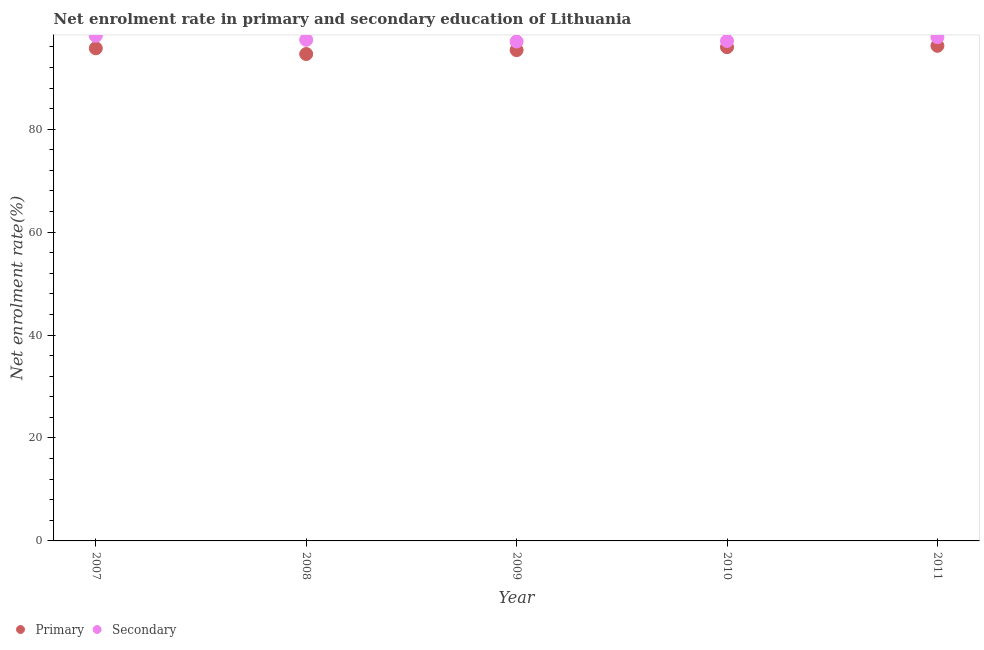How many different coloured dotlines are there?
Provide a short and direct response. 2. Is the number of dotlines equal to the number of legend labels?
Provide a short and direct response. Yes. What is the enrollment rate in secondary education in 2007?
Ensure brevity in your answer.  98.15. Across all years, what is the maximum enrollment rate in secondary education?
Provide a succinct answer. 98.15. Across all years, what is the minimum enrollment rate in secondary education?
Offer a very short reply. 97.03. In which year was the enrollment rate in secondary education maximum?
Your response must be concise. 2007. What is the total enrollment rate in primary education in the graph?
Your answer should be compact. 477.82. What is the difference between the enrollment rate in secondary education in 2009 and that in 2010?
Your answer should be compact. -0.11. What is the difference between the enrollment rate in primary education in 2007 and the enrollment rate in secondary education in 2010?
Offer a terse response. -1.43. What is the average enrollment rate in primary education per year?
Give a very brief answer. 95.56. In the year 2011, what is the difference between the enrollment rate in secondary education and enrollment rate in primary education?
Offer a terse response. 1.67. What is the ratio of the enrollment rate in secondary education in 2009 to that in 2010?
Offer a terse response. 1. What is the difference between the highest and the second highest enrollment rate in secondary education?
Your answer should be very brief. 0.27. What is the difference between the highest and the lowest enrollment rate in primary education?
Give a very brief answer. 1.6. In how many years, is the enrollment rate in primary education greater than the average enrollment rate in primary education taken over all years?
Offer a very short reply. 3. Is the sum of the enrollment rate in secondary education in 2007 and 2011 greater than the maximum enrollment rate in primary education across all years?
Your answer should be compact. Yes. Is the enrollment rate in secondary education strictly greater than the enrollment rate in primary education over the years?
Your response must be concise. Yes. How many dotlines are there?
Your answer should be very brief. 2. How many years are there in the graph?
Your response must be concise. 5. What is the difference between two consecutive major ticks on the Y-axis?
Ensure brevity in your answer.  20. Are the values on the major ticks of Y-axis written in scientific E-notation?
Your answer should be very brief. No. Does the graph contain grids?
Make the answer very short. No. What is the title of the graph?
Make the answer very short. Net enrolment rate in primary and secondary education of Lithuania. Does "IMF concessional" appear as one of the legend labels in the graph?
Provide a succinct answer. No. What is the label or title of the X-axis?
Your response must be concise. Year. What is the label or title of the Y-axis?
Ensure brevity in your answer.  Net enrolment rate(%). What is the Net enrolment rate(%) of Primary in 2007?
Make the answer very short. 95.71. What is the Net enrolment rate(%) in Secondary in 2007?
Keep it short and to the point. 98.15. What is the Net enrolment rate(%) of Primary in 2008?
Give a very brief answer. 94.61. What is the Net enrolment rate(%) in Secondary in 2008?
Your response must be concise. 97.37. What is the Net enrolment rate(%) in Primary in 2009?
Your response must be concise. 95.36. What is the Net enrolment rate(%) in Secondary in 2009?
Your answer should be compact. 97.03. What is the Net enrolment rate(%) of Primary in 2010?
Make the answer very short. 95.94. What is the Net enrolment rate(%) in Secondary in 2010?
Provide a short and direct response. 97.15. What is the Net enrolment rate(%) in Primary in 2011?
Keep it short and to the point. 96.2. What is the Net enrolment rate(%) of Secondary in 2011?
Your response must be concise. 97.88. Across all years, what is the maximum Net enrolment rate(%) of Primary?
Give a very brief answer. 96.2. Across all years, what is the maximum Net enrolment rate(%) of Secondary?
Make the answer very short. 98.15. Across all years, what is the minimum Net enrolment rate(%) in Primary?
Ensure brevity in your answer.  94.61. Across all years, what is the minimum Net enrolment rate(%) of Secondary?
Provide a short and direct response. 97.03. What is the total Net enrolment rate(%) in Primary in the graph?
Make the answer very short. 477.82. What is the total Net enrolment rate(%) of Secondary in the graph?
Ensure brevity in your answer.  487.57. What is the difference between the Net enrolment rate(%) of Primary in 2007 and that in 2008?
Offer a terse response. 1.11. What is the difference between the Net enrolment rate(%) in Secondary in 2007 and that in 2008?
Your answer should be very brief. 0.78. What is the difference between the Net enrolment rate(%) in Primary in 2007 and that in 2009?
Keep it short and to the point. 0.35. What is the difference between the Net enrolment rate(%) of Secondary in 2007 and that in 2009?
Make the answer very short. 1.11. What is the difference between the Net enrolment rate(%) of Primary in 2007 and that in 2010?
Offer a terse response. -0.22. What is the difference between the Net enrolment rate(%) in Primary in 2007 and that in 2011?
Offer a very short reply. -0.49. What is the difference between the Net enrolment rate(%) in Secondary in 2007 and that in 2011?
Give a very brief answer. 0.27. What is the difference between the Net enrolment rate(%) of Primary in 2008 and that in 2009?
Your answer should be compact. -0.76. What is the difference between the Net enrolment rate(%) in Secondary in 2008 and that in 2009?
Keep it short and to the point. 0.33. What is the difference between the Net enrolment rate(%) of Primary in 2008 and that in 2010?
Ensure brevity in your answer.  -1.33. What is the difference between the Net enrolment rate(%) in Secondary in 2008 and that in 2010?
Provide a succinct answer. 0.22. What is the difference between the Net enrolment rate(%) of Primary in 2008 and that in 2011?
Your answer should be very brief. -1.6. What is the difference between the Net enrolment rate(%) in Secondary in 2008 and that in 2011?
Give a very brief answer. -0.51. What is the difference between the Net enrolment rate(%) in Primary in 2009 and that in 2010?
Provide a short and direct response. -0.58. What is the difference between the Net enrolment rate(%) in Secondary in 2009 and that in 2010?
Ensure brevity in your answer.  -0.11. What is the difference between the Net enrolment rate(%) of Primary in 2009 and that in 2011?
Make the answer very short. -0.84. What is the difference between the Net enrolment rate(%) of Secondary in 2009 and that in 2011?
Make the answer very short. -0.84. What is the difference between the Net enrolment rate(%) in Primary in 2010 and that in 2011?
Offer a terse response. -0.26. What is the difference between the Net enrolment rate(%) in Secondary in 2010 and that in 2011?
Provide a succinct answer. -0.73. What is the difference between the Net enrolment rate(%) in Primary in 2007 and the Net enrolment rate(%) in Secondary in 2008?
Your answer should be compact. -1.65. What is the difference between the Net enrolment rate(%) of Primary in 2007 and the Net enrolment rate(%) of Secondary in 2009?
Offer a very short reply. -1.32. What is the difference between the Net enrolment rate(%) in Primary in 2007 and the Net enrolment rate(%) in Secondary in 2010?
Offer a very short reply. -1.43. What is the difference between the Net enrolment rate(%) of Primary in 2007 and the Net enrolment rate(%) of Secondary in 2011?
Your answer should be very brief. -2.16. What is the difference between the Net enrolment rate(%) in Primary in 2008 and the Net enrolment rate(%) in Secondary in 2009?
Give a very brief answer. -2.43. What is the difference between the Net enrolment rate(%) in Primary in 2008 and the Net enrolment rate(%) in Secondary in 2010?
Your response must be concise. -2.54. What is the difference between the Net enrolment rate(%) in Primary in 2008 and the Net enrolment rate(%) in Secondary in 2011?
Offer a very short reply. -3.27. What is the difference between the Net enrolment rate(%) of Primary in 2009 and the Net enrolment rate(%) of Secondary in 2010?
Your response must be concise. -1.78. What is the difference between the Net enrolment rate(%) in Primary in 2009 and the Net enrolment rate(%) in Secondary in 2011?
Make the answer very short. -2.51. What is the difference between the Net enrolment rate(%) in Primary in 2010 and the Net enrolment rate(%) in Secondary in 2011?
Your response must be concise. -1.94. What is the average Net enrolment rate(%) in Primary per year?
Keep it short and to the point. 95.56. What is the average Net enrolment rate(%) of Secondary per year?
Ensure brevity in your answer.  97.51. In the year 2007, what is the difference between the Net enrolment rate(%) in Primary and Net enrolment rate(%) in Secondary?
Your response must be concise. -2.43. In the year 2008, what is the difference between the Net enrolment rate(%) of Primary and Net enrolment rate(%) of Secondary?
Give a very brief answer. -2.76. In the year 2009, what is the difference between the Net enrolment rate(%) in Primary and Net enrolment rate(%) in Secondary?
Offer a very short reply. -1.67. In the year 2010, what is the difference between the Net enrolment rate(%) in Primary and Net enrolment rate(%) in Secondary?
Ensure brevity in your answer.  -1.21. In the year 2011, what is the difference between the Net enrolment rate(%) of Primary and Net enrolment rate(%) of Secondary?
Your response must be concise. -1.67. What is the ratio of the Net enrolment rate(%) in Primary in 2007 to that in 2008?
Your answer should be very brief. 1.01. What is the ratio of the Net enrolment rate(%) of Secondary in 2007 to that in 2009?
Your answer should be very brief. 1.01. What is the ratio of the Net enrolment rate(%) of Primary in 2007 to that in 2010?
Give a very brief answer. 1. What is the ratio of the Net enrolment rate(%) in Secondary in 2007 to that in 2010?
Ensure brevity in your answer.  1.01. What is the ratio of the Net enrolment rate(%) of Secondary in 2007 to that in 2011?
Your answer should be compact. 1. What is the ratio of the Net enrolment rate(%) in Primary in 2008 to that in 2009?
Keep it short and to the point. 0.99. What is the ratio of the Net enrolment rate(%) in Primary in 2008 to that in 2010?
Provide a succinct answer. 0.99. What is the ratio of the Net enrolment rate(%) in Primary in 2008 to that in 2011?
Make the answer very short. 0.98. What is the ratio of the Net enrolment rate(%) of Secondary in 2009 to that in 2010?
Provide a succinct answer. 1. What is the difference between the highest and the second highest Net enrolment rate(%) of Primary?
Offer a very short reply. 0.26. What is the difference between the highest and the second highest Net enrolment rate(%) in Secondary?
Your answer should be very brief. 0.27. What is the difference between the highest and the lowest Net enrolment rate(%) in Primary?
Offer a very short reply. 1.6. What is the difference between the highest and the lowest Net enrolment rate(%) of Secondary?
Offer a terse response. 1.11. 